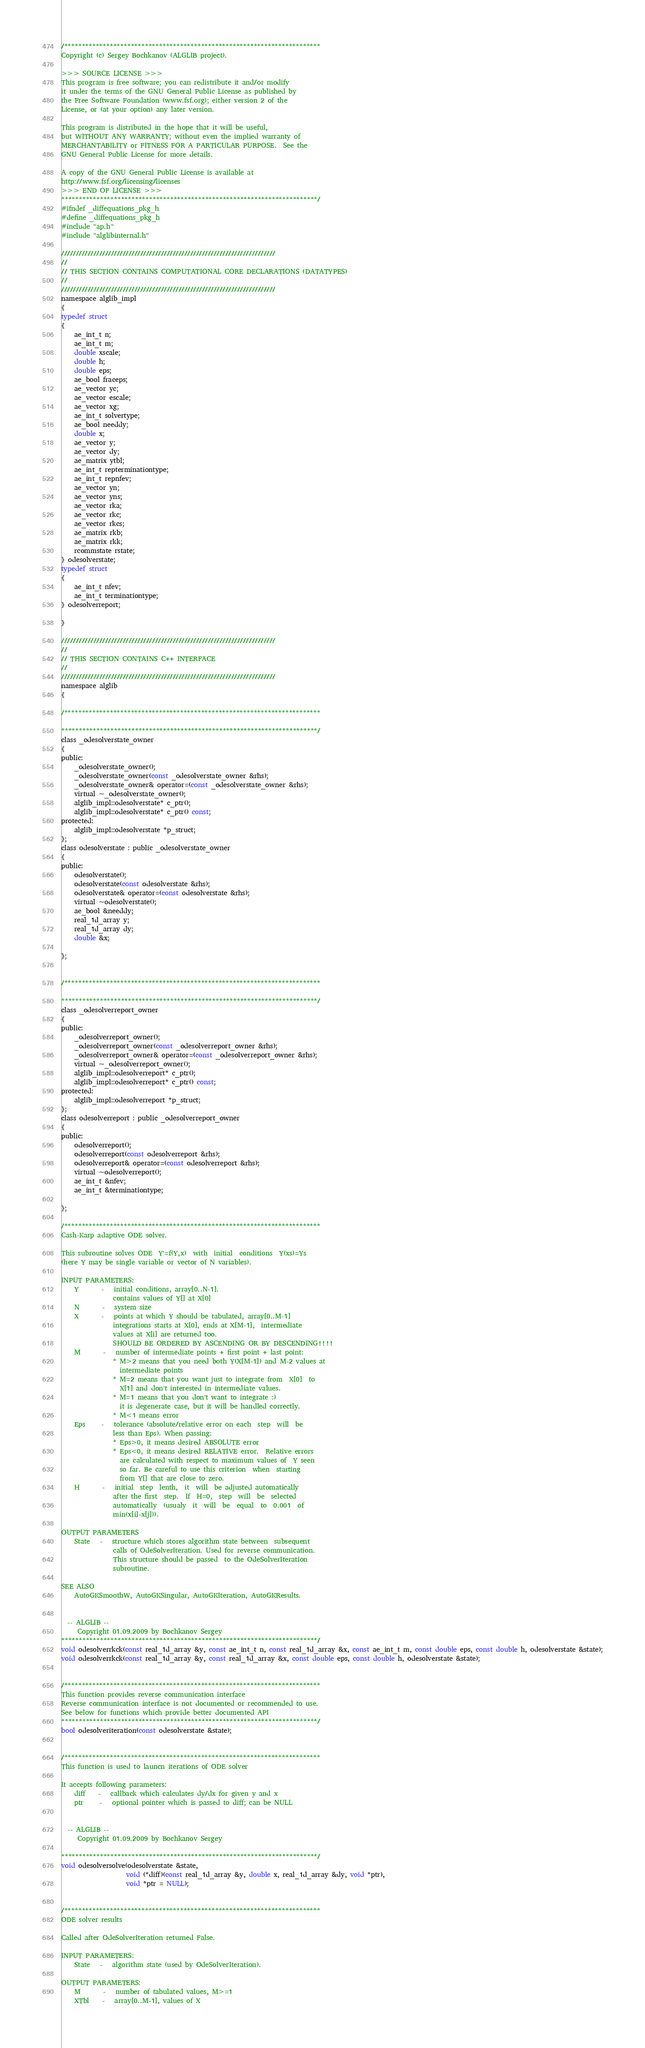<code> <loc_0><loc_0><loc_500><loc_500><_C_>/*************************************************************************
Copyright (c) Sergey Bochkanov (ALGLIB project).

>>> SOURCE LICENSE >>>
This program is free software; you can redistribute it and/or modify
it under the terms of the GNU General Public License as published by
the Free Software Foundation (www.fsf.org); either version 2 of the
License, or (at your option) any later version.

This program is distributed in the hope that it will be useful,
but WITHOUT ANY WARRANTY; without even the implied warranty of
MERCHANTABILITY or FITNESS FOR A PARTICULAR PURPOSE.  See the
GNU General Public License for more details.

A copy of the GNU General Public License is available at
http://www.fsf.org/licensing/licenses
>>> END OF LICENSE >>>
*************************************************************************/
#ifndef _diffequations_pkg_h
#define _diffequations_pkg_h
#include "ap.h"
#include "alglibinternal.h"

/////////////////////////////////////////////////////////////////////////
//
// THIS SECTION CONTAINS COMPUTATIONAL CORE DECLARATIONS (DATATYPES)
//
/////////////////////////////////////////////////////////////////////////
namespace alglib_impl
{
typedef struct
{
    ae_int_t n;
    ae_int_t m;
    double xscale;
    double h;
    double eps;
    ae_bool fraceps;
    ae_vector yc;
    ae_vector escale;
    ae_vector xg;
    ae_int_t solvertype;
    ae_bool needdy;
    double x;
    ae_vector y;
    ae_vector dy;
    ae_matrix ytbl;
    ae_int_t repterminationtype;
    ae_int_t repnfev;
    ae_vector yn;
    ae_vector yns;
    ae_vector rka;
    ae_vector rkc;
    ae_vector rkcs;
    ae_matrix rkb;
    ae_matrix rkk;
    rcommstate rstate;
} odesolverstate;
typedef struct
{
    ae_int_t nfev;
    ae_int_t terminationtype;
} odesolverreport;

}

/////////////////////////////////////////////////////////////////////////
//
// THIS SECTION CONTAINS C++ INTERFACE
//
/////////////////////////////////////////////////////////////////////////
namespace alglib
{

/*************************************************************************

*************************************************************************/
class _odesolverstate_owner
{
public:
    _odesolverstate_owner();
    _odesolverstate_owner(const _odesolverstate_owner &rhs);
    _odesolverstate_owner& operator=(const _odesolverstate_owner &rhs);
    virtual ~_odesolverstate_owner();
    alglib_impl::odesolverstate* c_ptr();
    alglib_impl::odesolverstate* c_ptr() const;
protected:
    alglib_impl::odesolverstate *p_struct;
};
class odesolverstate : public _odesolverstate_owner
{
public:
    odesolverstate();
    odesolverstate(const odesolverstate &rhs);
    odesolverstate& operator=(const odesolverstate &rhs);
    virtual ~odesolverstate();
    ae_bool &needdy;
    real_1d_array y;
    real_1d_array dy;
    double &x;

};


/*************************************************************************

*************************************************************************/
class _odesolverreport_owner
{
public:
    _odesolverreport_owner();
    _odesolverreport_owner(const _odesolverreport_owner &rhs);
    _odesolverreport_owner& operator=(const _odesolverreport_owner &rhs);
    virtual ~_odesolverreport_owner();
    alglib_impl::odesolverreport* c_ptr();
    alglib_impl::odesolverreport* c_ptr() const;
protected:
    alglib_impl::odesolverreport *p_struct;
};
class odesolverreport : public _odesolverreport_owner
{
public:
    odesolverreport();
    odesolverreport(const odesolverreport &rhs);
    odesolverreport& operator=(const odesolverreport &rhs);
    virtual ~odesolverreport();
    ae_int_t &nfev;
    ae_int_t &terminationtype;

};

/*************************************************************************
Cash-Karp adaptive ODE solver.

This subroutine solves ODE  Y'=f(Y,x)  with  initial  conditions  Y(xs)=Ys
(here Y may be single variable or vector of N variables).

INPUT PARAMETERS:
    Y       -   initial conditions, array[0..N-1].
                contains values of Y[] at X[0]
    N       -   system size
    X       -   points at which Y should be tabulated, array[0..M-1]
                integrations starts at X[0], ends at X[M-1],  intermediate
                values at X[i] are returned too.
                SHOULD BE ORDERED BY ASCENDING OR BY DESCENDING!!!!
    M       -   number of intermediate points + first point + last point:
                * M>2 means that you need both Y(X[M-1]) and M-2 values at
                  intermediate points
                * M=2 means that you want just to integrate from  X[0]  to
                  X[1] and don't interested in intermediate values.
                * M=1 means that you don't want to integrate :)
                  it is degenerate case, but it will be handled correctly.
                * M<1 means error
    Eps     -   tolerance (absolute/relative error on each  step  will  be
                less than Eps). When passing:
                * Eps>0, it means desired ABSOLUTE error
                * Eps<0, it means desired RELATIVE error.  Relative errors
                  are calculated with respect to maximum values of  Y seen
                  so far. Be careful to use this criterion  when  starting
                  from Y[] that are close to zero.
    H       -   initial  step  lenth,  it  will  be adjusted automatically
                after the first  step.  If  H=0,  step  will  be  selected
                automatically  (usualy  it  will  be  equal  to  0.001  of
                min(x[i]-x[j])).

OUTPUT PARAMETERS
    State   -   structure which stores algorithm state between  subsequent
                calls of OdeSolverIteration. Used for reverse communication.
                This structure should be passed  to the OdeSolverIteration
                subroutine.

SEE ALSO
    AutoGKSmoothW, AutoGKSingular, AutoGKIteration, AutoGKResults.


  -- ALGLIB --
     Copyright 01.09.2009 by Bochkanov Sergey
*************************************************************************/
void odesolverrkck(const real_1d_array &y, const ae_int_t n, const real_1d_array &x, const ae_int_t m, const double eps, const double h, odesolverstate &state);
void odesolverrkck(const real_1d_array &y, const real_1d_array &x, const double eps, const double h, odesolverstate &state);


/*************************************************************************
This function provides reverse communication interface
Reverse communication interface is not documented or recommended to use.
See below for functions which provide better documented API
*************************************************************************/
bool odesolveriteration(const odesolverstate &state);


/*************************************************************************
This function is used to launcn iterations of ODE solver

It accepts following parameters:
    diff    -   callback which calculates dy/dx for given y and x
    ptr     -   optional pointer which is passed to diff; can be NULL


  -- ALGLIB --
     Copyright 01.09.2009 by Bochkanov Sergey

*************************************************************************/
void odesolversolve(odesolverstate &state,
                    void (*diff)(const real_1d_array &y, double x, real_1d_array &dy, void *ptr),
                    void *ptr = NULL);


/*************************************************************************
ODE solver results

Called after OdeSolverIteration returned False.

INPUT PARAMETERS:
    State   -   algorithm state (used by OdeSolverIteration).

OUTPUT PARAMETERS:
    M       -   number of tabulated values, M>=1
    XTbl    -   array[0..M-1], values of X</code> 